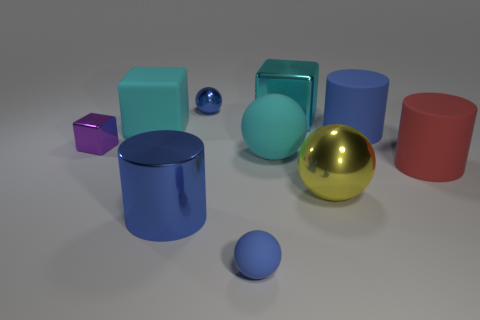Subtract 1 spheres. How many spheres are left? 3 Subtract all brown spheres. Subtract all brown cylinders. How many spheres are left? 4 Subtract all blocks. How many objects are left? 7 Subtract 0 gray cubes. How many objects are left? 10 Subtract all large cubes. Subtract all big objects. How many objects are left? 1 Add 4 big cyan matte things. How many big cyan matte things are left? 6 Add 8 big gray rubber things. How many big gray rubber things exist? 8 